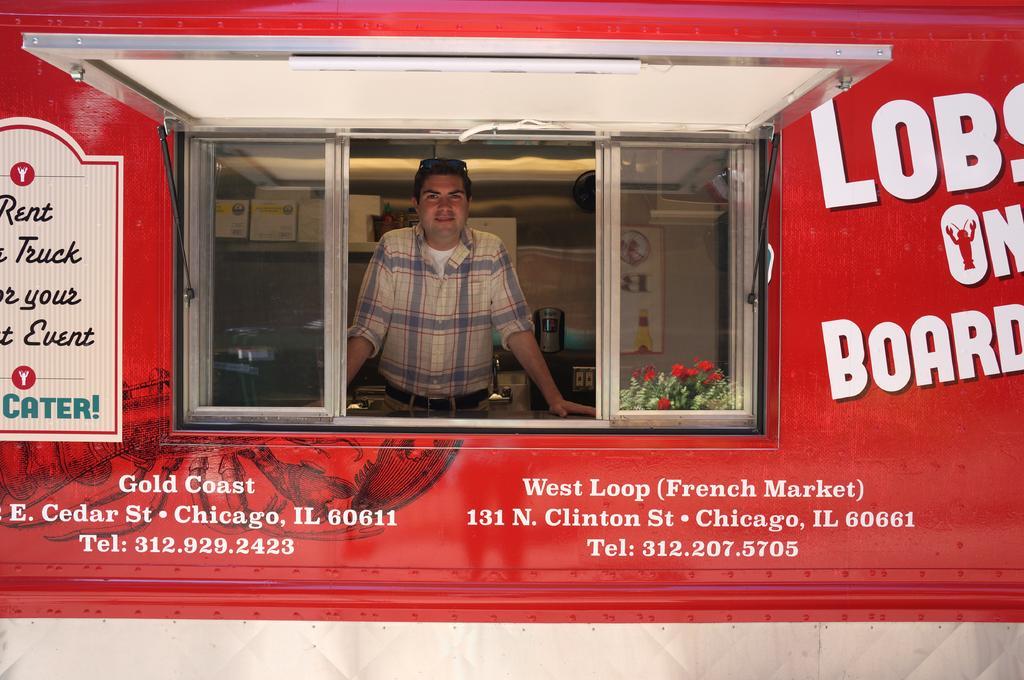Please provide a concise description of this image. In this image I can see a person standing in front of the window and person visible inside of building and in the backside of the window I can see flowers and I can see a red color wall and on the wall I can see text. 